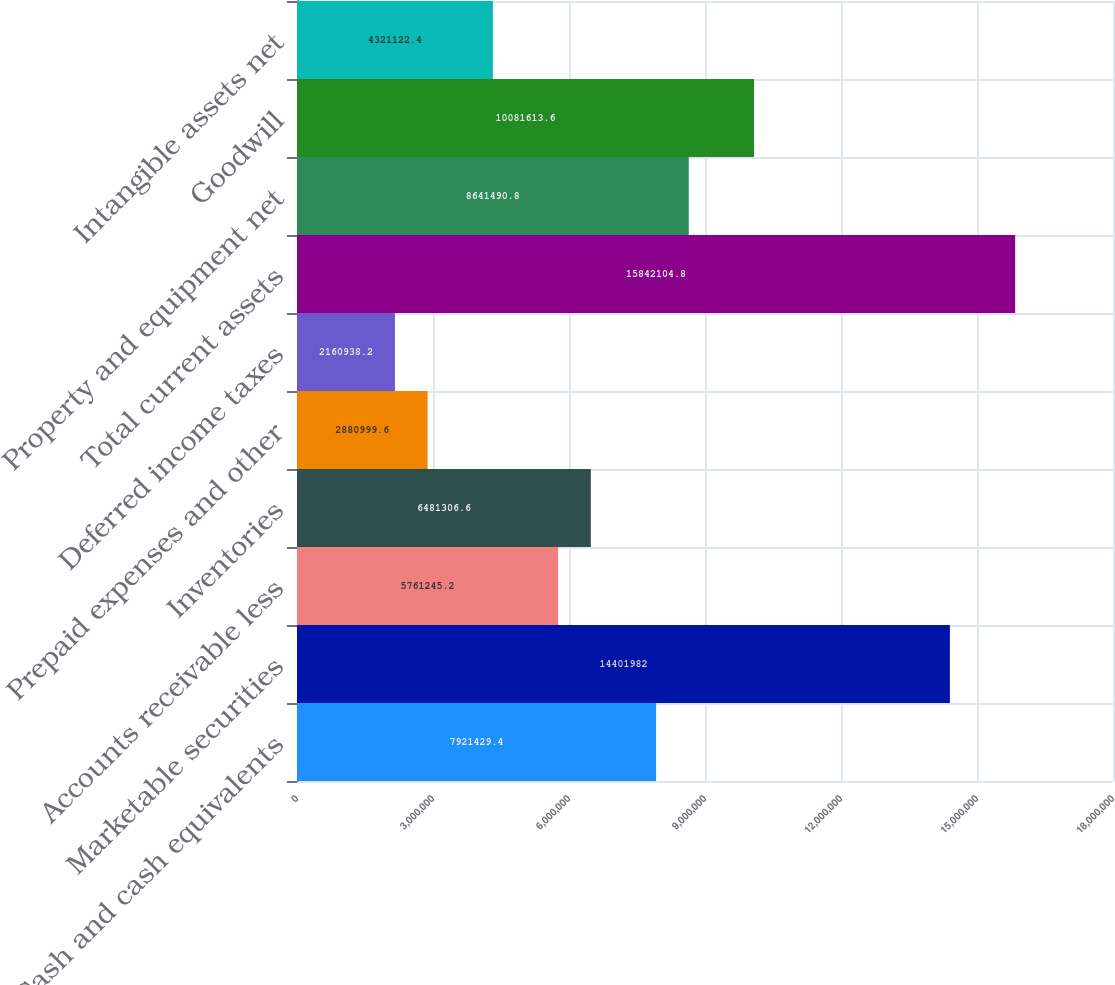<chart> <loc_0><loc_0><loc_500><loc_500><bar_chart><fcel>Cash and cash equivalents<fcel>Marketable securities<fcel>Accounts receivable less<fcel>Inventories<fcel>Prepaid expenses and other<fcel>Deferred income taxes<fcel>Total current assets<fcel>Property and equipment net<fcel>Goodwill<fcel>Intangible assets net<nl><fcel>7.92143e+06<fcel>1.4402e+07<fcel>5.76125e+06<fcel>6.48131e+06<fcel>2.881e+06<fcel>2.16094e+06<fcel>1.58421e+07<fcel>8.64149e+06<fcel>1.00816e+07<fcel>4.32112e+06<nl></chart> 